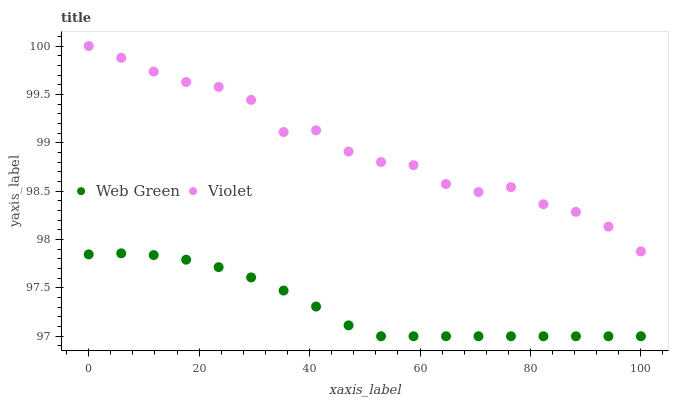Does Web Green have the minimum area under the curve?
Answer yes or no. Yes. Does Violet have the maximum area under the curve?
Answer yes or no. Yes. Does Violet have the minimum area under the curve?
Answer yes or no. No. Is Web Green the smoothest?
Answer yes or no. Yes. Is Violet the roughest?
Answer yes or no. Yes. Is Violet the smoothest?
Answer yes or no. No. Does Web Green have the lowest value?
Answer yes or no. Yes. Does Violet have the lowest value?
Answer yes or no. No. Does Violet have the highest value?
Answer yes or no. Yes. Is Web Green less than Violet?
Answer yes or no. Yes. Is Violet greater than Web Green?
Answer yes or no. Yes. Does Web Green intersect Violet?
Answer yes or no. No. 